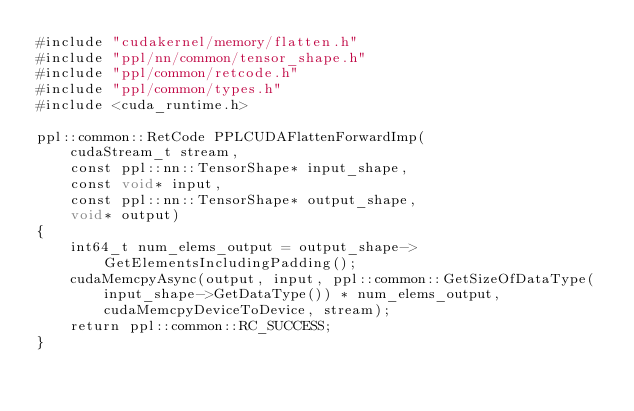<code> <loc_0><loc_0><loc_500><loc_500><_Cuda_>#include "cudakernel/memory/flatten.h"
#include "ppl/nn/common/tensor_shape.h"
#include "ppl/common/retcode.h"
#include "ppl/common/types.h"
#include <cuda_runtime.h>

ppl::common::RetCode PPLCUDAFlattenForwardImp(
    cudaStream_t stream,
    const ppl::nn::TensorShape* input_shape,
    const void* input,
    const ppl::nn::TensorShape* output_shape,
    void* output)
{
    int64_t num_elems_output = output_shape->GetElementsIncludingPadding();
    cudaMemcpyAsync(output, input, ppl::common::GetSizeOfDataType(input_shape->GetDataType()) * num_elems_output, cudaMemcpyDeviceToDevice, stream);
    return ppl::common::RC_SUCCESS;
}</code> 